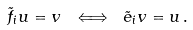Convert formula to latex. <formula><loc_0><loc_0><loc_500><loc_500>\tilde { f } _ { i } u = v \ \Longleftrightarrow \ \tilde { e } _ { i } v = u \, .</formula> 